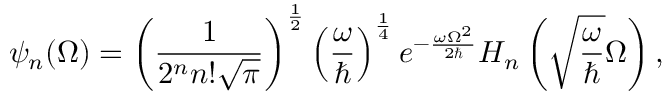<formula> <loc_0><loc_0><loc_500><loc_500>\psi _ { n } ( \Omega ) = \left ( \frac { 1 } { 2 ^ { n } n ! \sqrt { \pi } } \right ) ^ { \frac { 1 } { 2 } } \left ( \frac { \omega } { } \right ) ^ { \frac { 1 } { 4 } } e ^ { - \frac { \omega \Omega ^ { 2 } } { 2 } } H _ { n } \left ( \sqrt { \frac { \omega } { } } \Omega \right ) ,</formula> 